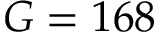<formula> <loc_0><loc_0><loc_500><loc_500>G = 1 6 8</formula> 